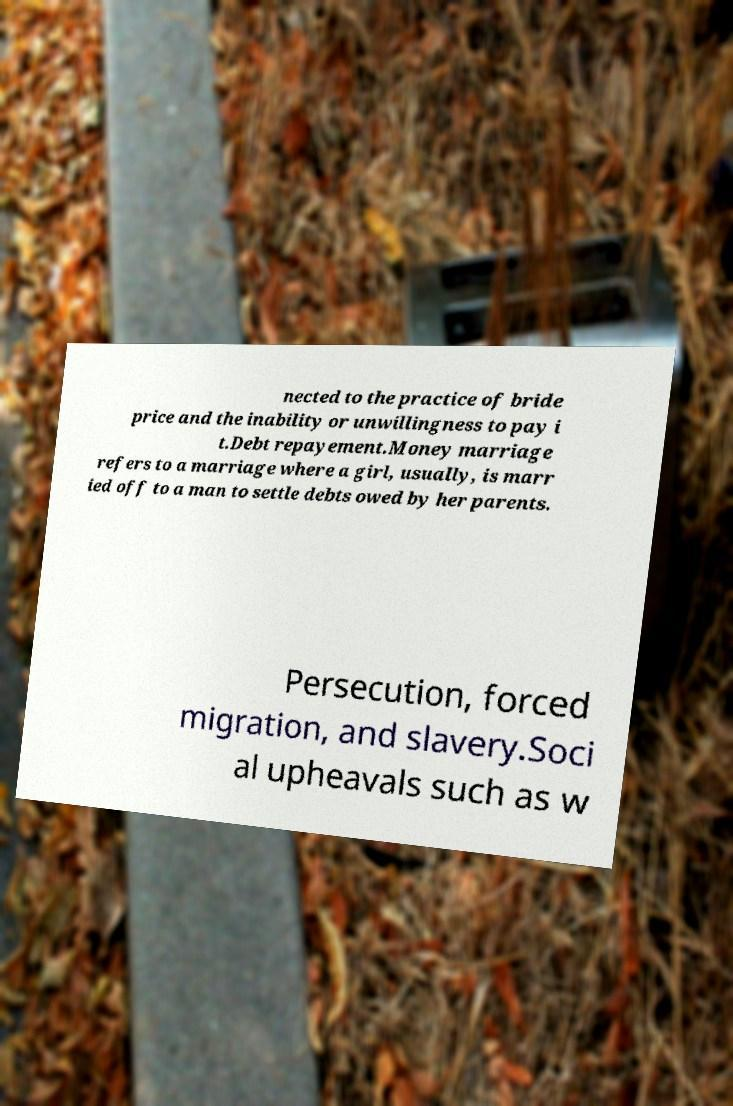I need the written content from this picture converted into text. Can you do that? nected to the practice of bride price and the inability or unwillingness to pay i t.Debt repayement.Money marriage refers to a marriage where a girl, usually, is marr ied off to a man to settle debts owed by her parents. Persecution, forced migration, and slavery.Soci al upheavals such as w 